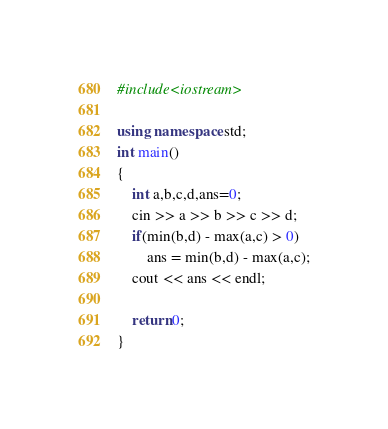Convert code to text. <code><loc_0><loc_0><loc_500><loc_500><_C++_>#include<iostream>

using namespace std;
int main()
{
	int a,b,c,d,ans=0;
	cin >> a >> b >> c >> d;
	if(min(b,d) - max(a,c) > 0)
		ans = min(b,d) - max(a,c);
	cout << ans << endl;
	
	return 0;
}
</code> 